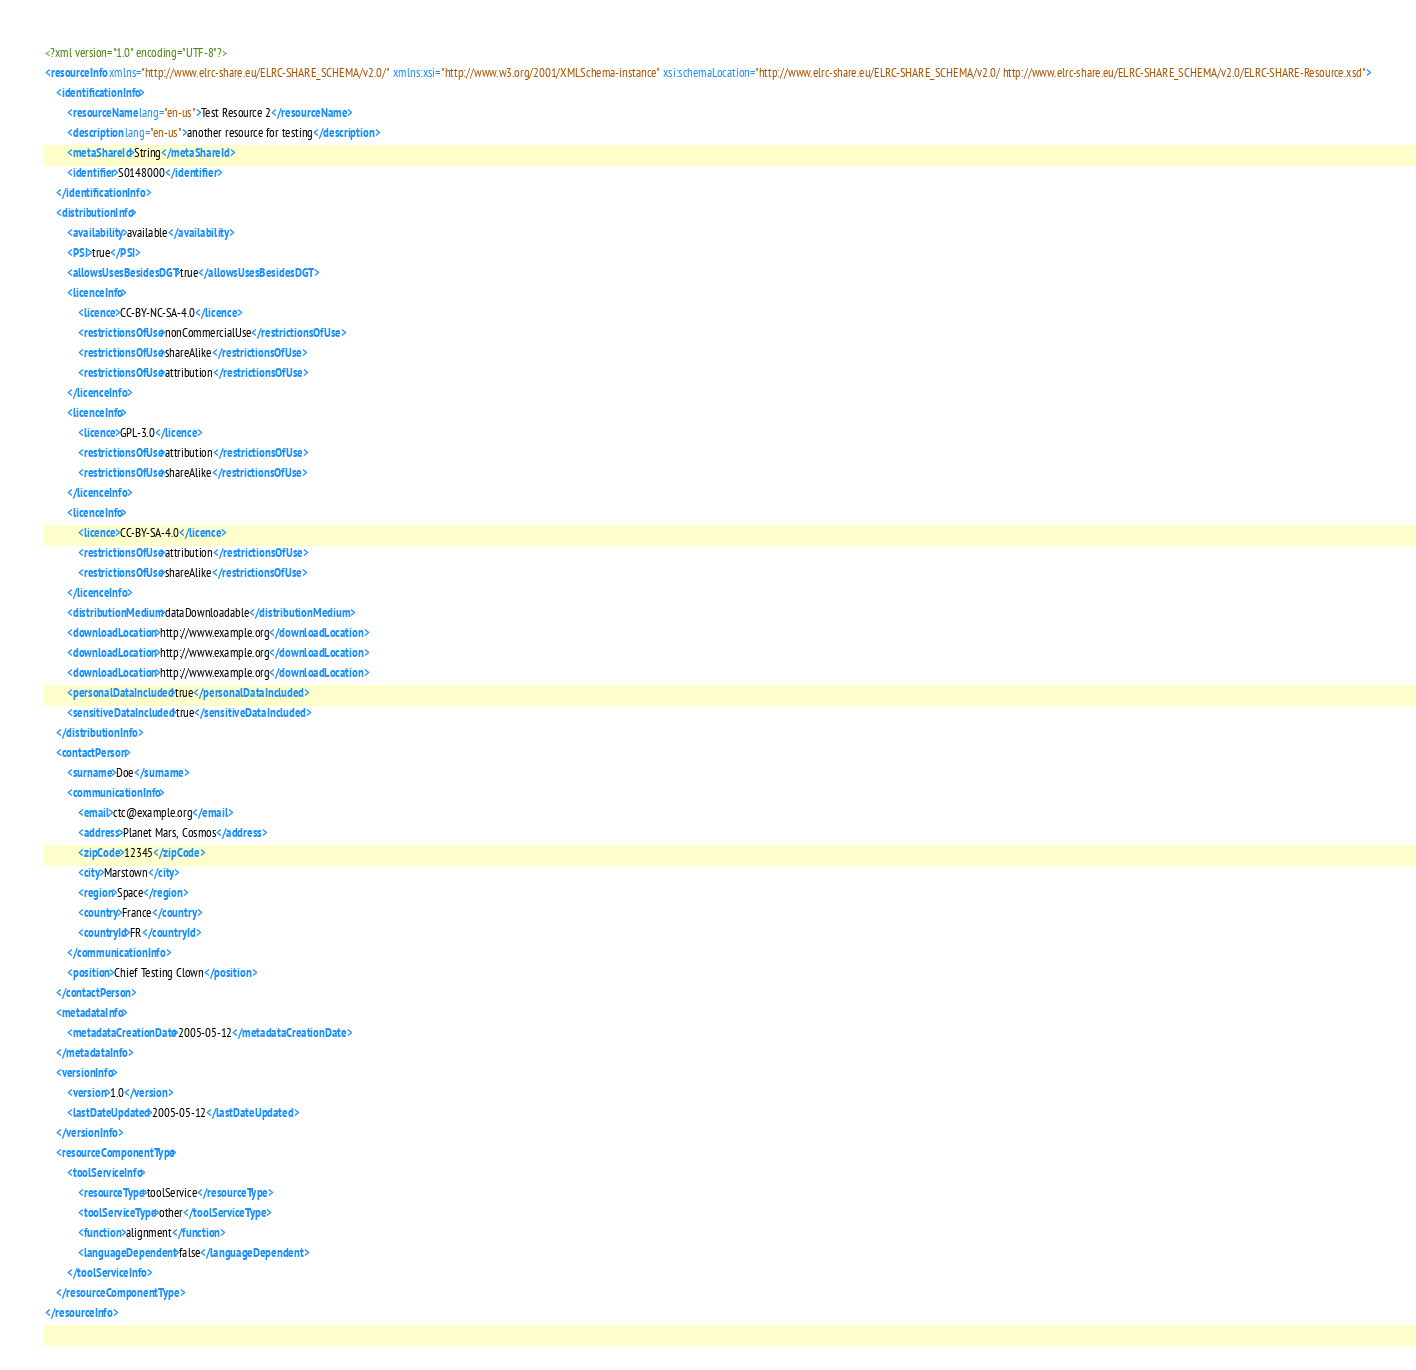Convert code to text. <code><loc_0><loc_0><loc_500><loc_500><_XML_><?xml version="1.0" encoding="UTF-8"?>
<resourceInfo xmlns="http://www.elrc-share.eu/ELRC-SHARE_SCHEMA/v2.0/" xmlns:xsi="http://www.w3.org/2001/XMLSchema-instance" xsi:schemaLocation="http://www.elrc-share.eu/ELRC-SHARE_SCHEMA/v2.0/ http://www.elrc-share.eu/ELRC-SHARE_SCHEMA/v2.0/ELRC-SHARE-Resource.xsd">
	<identificationInfo>
		<resourceName lang="en-us">Test Resource 2</resourceName>
		<description lang="en-us">another resource for testing</description>
		<metaShareId>String</metaShareId>
		<identifier>S0148000</identifier>
	</identificationInfo>
	<distributionInfo>
		<availability>available</availability>
		<PSI>true</PSI>
		<allowsUsesBesidesDGT>true</allowsUsesBesidesDGT>
		<licenceInfo>
			<licence>CC-BY-NC-SA-4.0</licence>
			<restrictionsOfUse>nonCommercialUse</restrictionsOfUse>
			<restrictionsOfUse>shareAlike</restrictionsOfUse>
			<restrictionsOfUse>attribution</restrictionsOfUse>
		</licenceInfo>
		<licenceInfo>
			<licence>GPL-3.0</licence>
			<restrictionsOfUse>attribution</restrictionsOfUse>
			<restrictionsOfUse>shareAlike</restrictionsOfUse>
		</licenceInfo>
		<licenceInfo>
			<licence>CC-BY-SA-4.0</licence>
			<restrictionsOfUse>attribution</restrictionsOfUse>
			<restrictionsOfUse>shareAlike</restrictionsOfUse>
		</licenceInfo>
		<distributionMedium>dataDownloadable</distributionMedium>
		<downloadLocation>http://www.example.org</downloadLocation>
		<downloadLocation>http://www.example.org</downloadLocation>
		<downloadLocation>http://www.example.org</downloadLocation>
		<personalDataIncluded>true</personalDataIncluded>
		<sensitiveDataIncluded>true</sensitiveDataIncluded>
	</distributionInfo>
	<contactPerson>
		<surname>Doe</surname>
		<communicationInfo>
			<email>ctc@example.org</email>
			<address>Planet Mars, Cosmos</address>
			<zipCode>12345</zipCode>
			<city>Marstown</city>
			<region>Space</region>
			<country>France</country>
			<countryId>FR</countryId>
		</communicationInfo>
		<position>Chief Testing Clown</position>
	</contactPerson>
	<metadataInfo>
		<metadataCreationDate>2005-05-12</metadataCreationDate>
	</metadataInfo>
	<versionInfo>
		<version>1.0</version>
		<lastDateUpdated>2005-05-12</lastDateUpdated>
	</versionInfo>
	<resourceComponentType>
		<toolServiceInfo>
			<resourceType>toolService</resourceType>
			<toolServiceType>other</toolServiceType>
			<function>alignment</function>
			<languageDependent>false</languageDependent>
		</toolServiceInfo>
	</resourceComponentType>
</resourceInfo></code> 